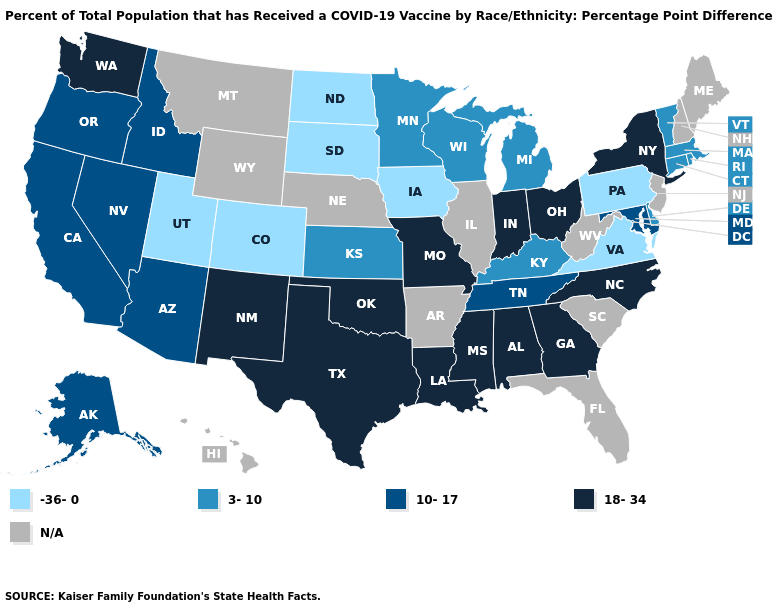What is the value of Alabama?
Give a very brief answer. 18-34. What is the lowest value in the Northeast?
Answer briefly. -36-0. Does the map have missing data?
Quick response, please. Yes. How many symbols are there in the legend?
Short answer required. 5. Among the states that border Arkansas , which have the lowest value?
Write a very short answer. Tennessee. What is the lowest value in states that border Virginia?
Answer briefly. 3-10. Which states have the highest value in the USA?
Short answer required. Alabama, Georgia, Indiana, Louisiana, Mississippi, Missouri, New Mexico, New York, North Carolina, Ohio, Oklahoma, Texas, Washington. What is the value of Wyoming?
Keep it brief. N/A. Name the states that have a value in the range -36-0?
Short answer required. Colorado, Iowa, North Dakota, Pennsylvania, South Dakota, Utah, Virginia. What is the highest value in the USA?
Write a very short answer. 18-34. What is the value of Texas?
Give a very brief answer. 18-34. Is the legend a continuous bar?
Short answer required. No. What is the value of Nebraska?
Answer briefly. N/A. Among the states that border Nevada , which have the highest value?
Quick response, please. Arizona, California, Idaho, Oregon. Does Tennessee have the highest value in the South?
Be succinct. No. 